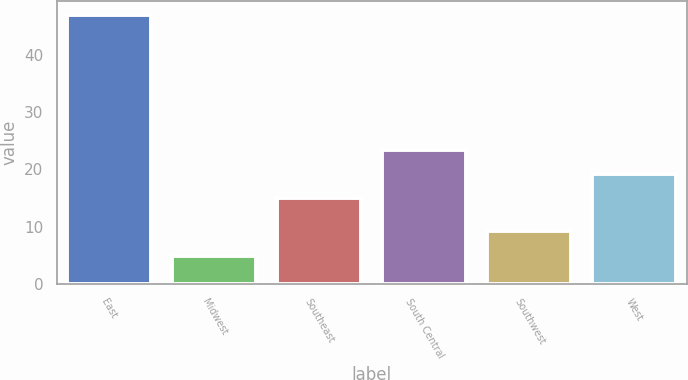Convert chart to OTSL. <chart><loc_0><loc_0><loc_500><loc_500><bar_chart><fcel>East<fcel>Midwest<fcel>Southeast<fcel>South Central<fcel>Southwest<fcel>West<nl><fcel>47<fcel>5<fcel>15<fcel>23.4<fcel>9.2<fcel>19.2<nl></chart> 